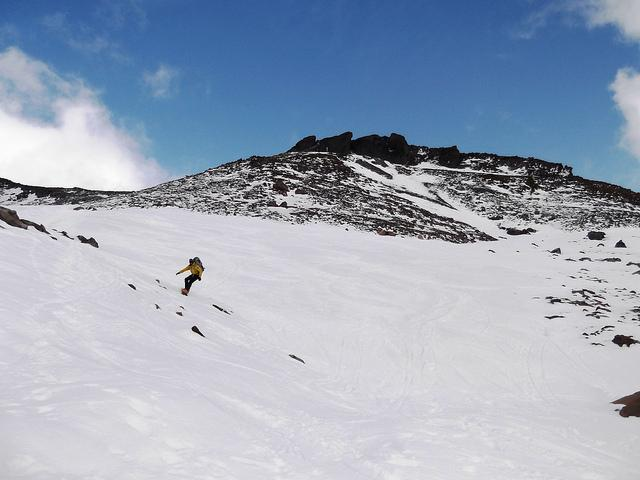What sort of weather happens here frequently? snow 